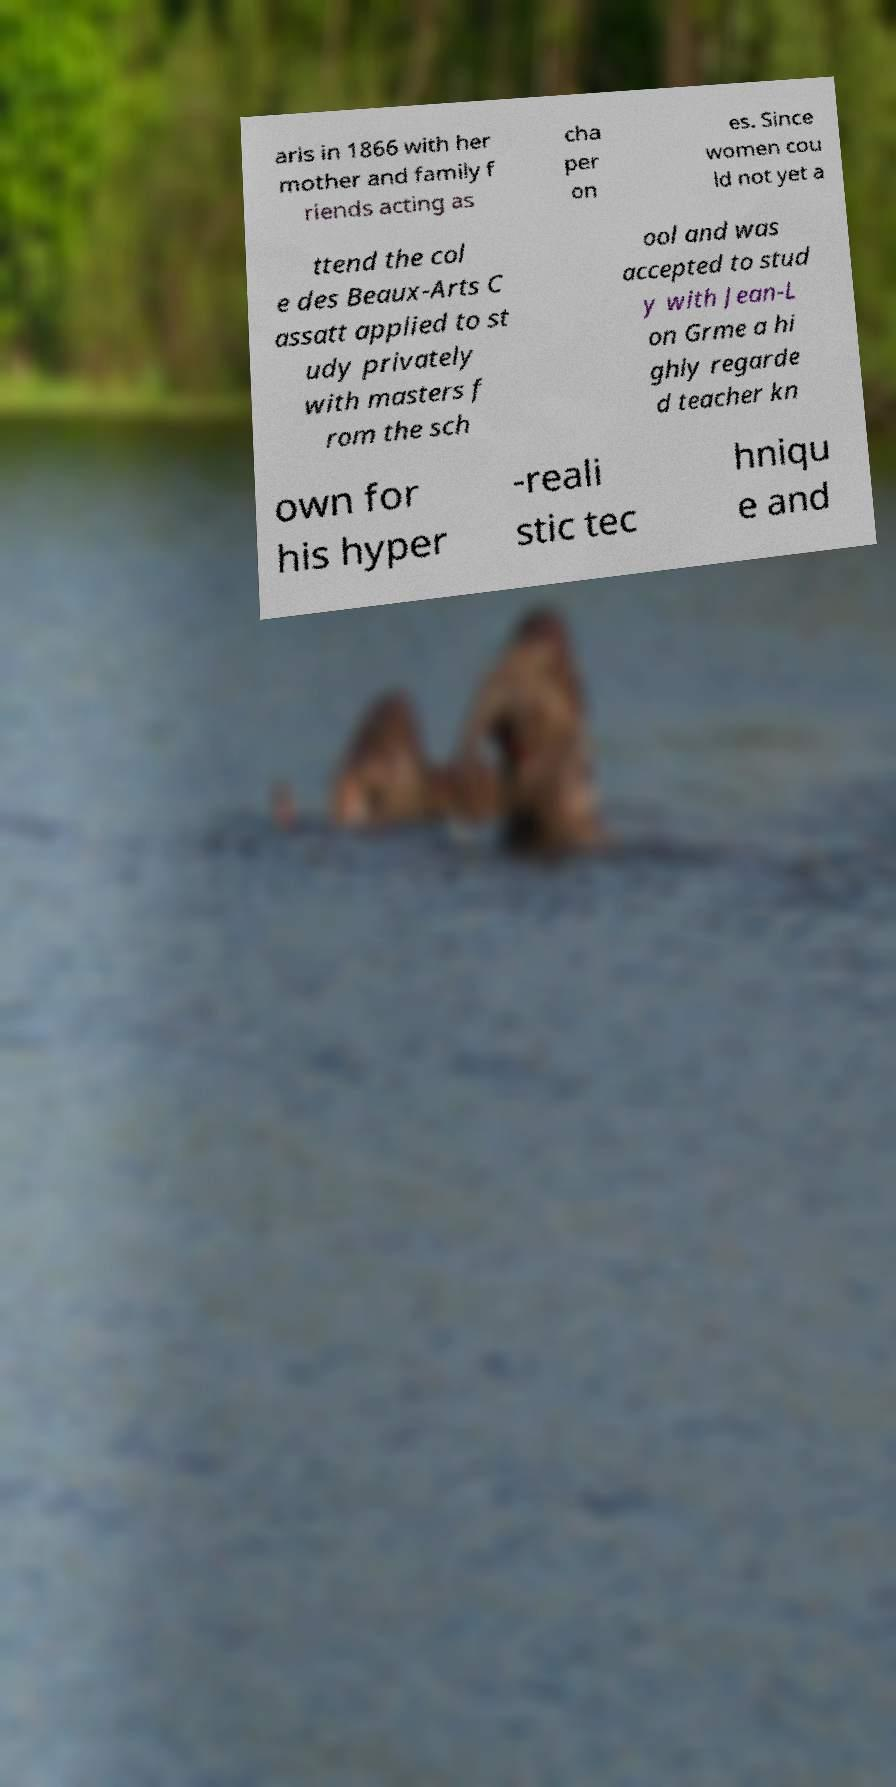What messages or text are displayed in this image? I need them in a readable, typed format. aris in 1866 with her mother and family f riends acting as cha per on es. Since women cou ld not yet a ttend the col e des Beaux-Arts C assatt applied to st udy privately with masters f rom the sch ool and was accepted to stud y with Jean-L on Grme a hi ghly regarde d teacher kn own for his hyper -reali stic tec hniqu e and 